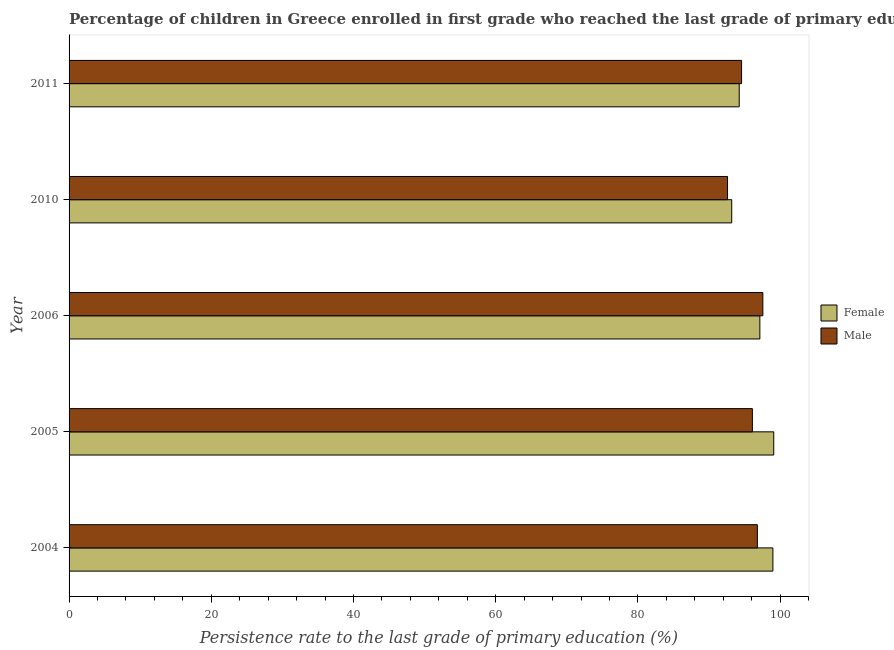How many groups of bars are there?
Give a very brief answer. 5. Are the number of bars per tick equal to the number of legend labels?
Your answer should be compact. Yes. Are the number of bars on each tick of the Y-axis equal?
Keep it short and to the point. Yes. In how many cases, is the number of bars for a given year not equal to the number of legend labels?
Ensure brevity in your answer.  0. What is the persistence rate of female students in 2010?
Your answer should be very brief. 93.19. Across all years, what is the maximum persistence rate of male students?
Make the answer very short. 97.57. Across all years, what is the minimum persistence rate of female students?
Ensure brevity in your answer.  93.19. In which year was the persistence rate of male students minimum?
Your response must be concise. 2010. What is the total persistence rate of male students in the graph?
Offer a terse response. 477.65. What is the difference between the persistence rate of male students in 2005 and that in 2011?
Your answer should be compact. 1.52. What is the difference between the persistence rate of male students in 2011 and the persistence rate of female students in 2004?
Your answer should be very brief. -4.41. What is the average persistence rate of male students per year?
Make the answer very short. 95.53. In the year 2011, what is the difference between the persistence rate of male students and persistence rate of female students?
Give a very brief answer. 0.33. In how many years, is the persistence rate of male students greater than 4 %?
Provide a succinct answer. 5. What is the ratio of the persistence rate of female students in 2010 to that in 2011?
Give a very brief answer. 0.99. What is the difference between the highest and the second highest persistence rate of female students?
Give a very brief answer. 0.12. What is the difference between the highest and the lowest persistence rate of female students?
Give a very brief answer. 5.91. In how many years, is the persistence rate of male students greater than the average persistence rate of male students taken over all years?
Your answer should be compact. 3. What does the 1st bar from the top in 2006 represents?
Make the answer very short. Male. What does the 2nd bar from the bottom in 2011 represents?
Provide a succinct answer. Male. Are all the bars in the graph horizontal?
Give a very brief answer. Yes. Are the values on the major ticks of X-axis written in scientific E-notation?
Give a very brief answer. No. Where does the legend appear in the graph?
Provide a short and direct response. Center right. How many legend labels are there?
Give a very brief answer. 2. How are the legend labels stacked?
Your answer should be compact. Vertical. What is the title of the graph?
Keep it short and to the point. Percentage of children in Greece enrolled in first grade who reached the last grade of primary education. What is the label or title of the X-axis?
Keep it short and to the point. Persistence rate to the last grade of primary education (%). What is the label or title of the Y-axis?
Provide a succinct answer. Year. What is the Persistence rate to the last grade of primary education (%) of Female in 2004?
Provide a short and direct response. 98.99. What is the Persistence rate to the last grade of primary education (%) of Male in 2004?
Ensure brevity in your answer.  96.8. What is the Persistence rate to the last grade of primary education (%) in Female in 2005?
Provide a short and direct response. 99.1. What is the Persistence rate to the last grade of primary education (%) of Male in 2005?
Make the answer very short. 96.1. What is the Persistence rate to the last grade of primary education (%) of Female in 2006?
Give a very brief answer. 97.15. What is the Persistence rate to the last grade of primary education (%) of Male in 2006?
Offer a terse response. 97.57. What is the Persistence rate to the last grade of primary education (%) in Female in 2010?
Offer a terse response. 93.19. What is the Persistence rate to the last grade of primary education (%) of Male in 2010?
Offer a very short reply. 92.6. What is the Persistence rate to the last grade of primary education (%) of Female in 2011?
Ensure brevity in your answer.  94.25. What is the Persistence rate to the last grade of primary education (%) in Male in 2011?
Provide a succinct answer. 94.58. Across all years, what is the maximum Persistence rate to the last grade of primary education (%) in Female?
Provide a succinct answer. 99.1. Across all years, what is the maximum Persistence rate to the last grade of primary education (%) in Male?
Make the answer very short. 97.57. Across all years, what is the minimum Persistence rate to the last grade of primary education (%) of Female?
Provide a short and direct response. 93.19. Across all years, what is the minimum Persistence rate to the last grade of primary education (%) in Male?
Make the answer very short. 92.6. What is the total Persistence rate to the last grade of primary education (%) in Female in the graph?
Your answer should be compact. 482.68. What is the total Persistence rate to the last grade of primary education (%) of Male in the graph?
Keep it short and to the point. 477.65. What is the difference between the Persistence rate to the last grade of primary education (%) of Female in 2004 and that in 2005?
Keep it short and to the point. -0.12. What is the difference between the Persistence rate to the last grade of primary education (%) of Male in 2004 and that in 2005?
Offer a very short reply. 0.7. What is the difference between the Persistence rate to the last grade of primary education (%) in Female in 2004 and that in 2006?
Your response must be concise. 1.84. What is the difference between the Persistence rate to the last grade of primary education (%) in Male in 2004 and that in 2006?
Provide a succinct answer. -0.77. What is the difference between the Persistence rate to the last grade of primary education (%) in Female in 2004 and that in 2010?
Make the answer very short. 5.79. What is the difference between the Persistence rate to the last grade of primary education (%) in Male in 2004 and that in 2010?
Make the answer very short. 4.2. What is the difference between the Persistence rate to the last grade of primary education (%) of Female in 2004 and that in 2011?
Ensure brevity in your answer.  4.74. What is the difference between the Persistence rate to the last grade of primary education (%) in Male in 2004 and that in 2011?
Offer a very short reply. 2.22. What is the difference between the Persistence rate to the last grade of primary education (%) in Female in 2005 and that in 2006?
Provide a succinct answer. 1.95. What is the difference between the Persistence rate to the last grade of primary education (%) of Male in 2005 and that in 2006?
Provide a short and direct response. -1.47. What is the difference between the Persistence rate to the last grade of primary education (%) of Female in 2005 and that in 2010?
Provide a succinct answer. 5.91. What is the difference between the Persistence rate to the last grade of primary education (%) of Male in 2005 and that in 2010?
Keep it short and to the point. 3.49. What is the difference between the Persistence rate to the last grade of primary education (%) in Female in 2005 and that in 2011?
Keep it short and to the point. 4.85. What is the difference between the Persistence rate to the last grade of primary education (%) of Male in 2005 and that in 2011?
Offer a terse response. 1.52. What is the difference between the Persistence rate to the last grade of primary education (%) of Female in 2006 and that in 2010?
Make the answer very short. 3.96. What is the difference between the Persistence rate to the last grade of primary education (%) of Male in 2006 and that in 2010?
Offer a terse response. 4.97. What is the difference between the Persistence rate to the last grade of primary education (%) of Female in 2006 and that in 2011?
Your answer should be very brief. 2.9. What is the difference between the Persistence rate to the last grade of primary education (%) of Male in 2006 and that in 2011?
Make the answer very short. 2.99. What is the difference between the Persistence rate to the last grade of primary education (%) in Female in 2010 and that in 2011?
Your response must be concise. -1.05. What is the difference between the Persistence rate to the last grade of primary education (%) of Male in 2010 and that in 2011?
Ensure brevity in your answer.  -1.98. What is the difference between the Persistence rate to the last grade of primary education (%) in Female in 2004 and the Persistence rate to the last grade of primary education (%) in Male in 2005?
Your response must be concise. 2.89. What is the difference between the Persistence rate to the last grade of primary education (%) of Female in 2004 and the Persistence rate to the last grade of primary education (%) of Male in 2006?
Offer a terse response. 1.41. What is the difference between the Persistence rate to the last grade of primary education (%) of Female in 2004 and the Persistence rate to the last grade of primary education (%) of Male in 2010?
Make the answer very short. 6.38. What is the difference between the Persistence rate to the last grade of primary education (%) of Female in 2004 and the Persistence rate to the last grade of primary education (%) of Male in 2011?
Make the answer very short. 4.41. What is the difference between the Persistence rate to the last grade of primary education (%) in Female in 2005 and the Persistence rate to the last grade of primary education (%) in Male in 2006?
Keep it short and to the point. 1.53. What is the difference between the Persistence rate to the last grade of primary education (%) in Female in 2005 and the Persistence rate to the last grade of primary education (%) in Male in 2010?
Your answer should be very brief. 6.5. What is the difference between the Persistence rate to the last grade of primary education (%) in Female in 2005 and the Persistence rate to the last grade of primary education (%) in Male in 2011?
Your response must be concise. 4.52. What is the difference between the Persistence rate to the last grade of primary education (%) of Female in 2006 and the Persistence rate to the last grade of primary education (%) of Male in 2010?
Ensure brevity in your answer.  4.55. What is the difference between the Persistence rate to the last grade of primary education (%) in Female in 2006 and the Persistence rate to the last grade of primary education (%) in Male in 2011?
Give a very brief answer. 2.57. What is the difference between the Persistence rate to the last grade of primary education (%) of Female in 2010 and the Persistence rate to the last grade of primary education (%) of Male in 2011?
Keep it short and to the point. -1.39. What is the average Persistence rate to the last grade of primary education (%) of Female per year?
Provide a succinct answer. 96.54. What is the average Persistence rate to the last grade of primary education (%) of Male per year?
Provide a succinct answer. 95.53. In the year 2004, what is the difference between the Persistence rate to the last grade of primary education (%) of Female and Persistence rate to the last grade of primary education (%) of Male?
Offer a very short reply. 2.18. In the year 2005, what is the difference between the Persistence rate to the last grade of primary education (%) of Female and Persistence rate to the last grade of primary education (%) of Male?
Ensure brevity in your answer.  3.01. In the year 2006, what is the difference between the Persistence rate to the last grade of primary education (%) of Female and Persistence rate to the last grade of primary education (%) of Male?
Your response must be concise. -0.42. In the year 2010, what is the difference between the Persistence rate to the last grade of primary education (%) of Female and Persistence rate to the last grade of primary education (%) of Male?
Your answer should be compact. 0.59. In the year 2011, what is the difference between the Persistence rate to the last grade of primary education (%) in Female and Persistence rate to the last grade of primary education (%) in Male?
Give a very brief answer. -0.33. What is the ratio of the Persistence rate to the last grade of primary education (%) of Female in 2004 to that in 2005?
Ensure brevity in your answer.  1. What is the ratio of the Persistence rate to the last grade of primary education (%) in Male in 2004 to that in 2005?
Keep it short and to the point. 1.01. What is the ratio of the Persistence rate to the last grade of primary education (%) in Female in 2004 to that in 2006?
Provide a succinct answer. 1.02. What is the ratio of the Persistence rate to the last grade of primary education (%) in Male in 2004 to that in 2006?
Your response must be concise. 0.99. What is the ratio of the Persistence rate to the last grade of primary education (%) in Female in 2004 to that in 2010?
Your answer should be very brief. 1.06. What is the ratio of the Persistence rate to the last grade of primary education (%) in Male in 2004 to that in 2010?
Make the answer very short. 1.05. What is the ratio of the Persistence rate to the last grade of primary education (%) of Female in 2004 to that in 2011?
Offer a very short reply. 1.05. What is the ratio of the Persistence rate to the last grade of primary education (%) in Male in 2004 to that in 2011?
Provide a short and direct response. 1.02. What is the ratio of the Persistence rate to the last grade of primary education (%) of Female in 2005 to that in 2006?
Your response must be concise. 1.02. What is the ratio of the Persistence rate to the last grade of primary education (%) in Male in 2005 to that in 2006?
Give a very brief answer. 0.98. What is the ratio of the Persistence rate to the last grade of primary education (%) in Female in 2005 to that in 2010?
Your response must be concise. 1.06. What is the ratio of the Persistence rate to the last grade of primary education (%) of Male in 2005 to that in 2010?
Offer a terse response. 1.04. What is the ratio of the Persistence rate to the last grade of primary education (%) of Female in 2005 to that in 2011?
Offer a very short reply. 1.05. What is the ratio of the Persistence rate to the last grade of primary education (%) of Male in 2005 to that in 2011?
Ensure brevity in your answer.  1.02. What is the ratio of the Persistence rate to the last grade of primary education (%) of Female in 2006 to that in 2010?
Provide a short and direct response. 1.04. What is the ratio of the Persistence rate to the last grade of primary education (%) in Male in 2006 to that in 2010?
Keep it short and to the point. 1.05. What is the ratio of the Persistence rate to the last grade of primary education (%) of Female in 2006 to that in 2011?
Ensure brevity in your answer.  1.03. What is the ratio of the Persistence rate to the last grade of primary education (%) of Male in 2006 to that in 2011?
Keep it short and to the point. 1.03. What is the ratio of the Persistence rate to the last grade of primary education (%) in Female in 2010 to that in 2011?
Offer a very short reply. 0.99. What is the ratio of the Persistence rate to the last grade of primary education (%) in Male in 2010 to that in 2011?
Offer a terse response. 0.98. What is the difference between the highest and the second highest Persistence rate to the last grade of primary education (%) of Female?
Provide a succinct answer. 0.12. What is the difference between the highest and the second highest Persistence rate to the last grade of primary education (%) of Male?
Keep it short and to the point. 0.77. What is the difference between the highest and the lowest Persistence rate to the last grade of primary education (%) of Female?
Your answer should be compact. 5.91. What is the difference between the highest and the lowest Persistence rate to the last grade of primary education (%) of Male?
Provide a short and direct response. 4.97. 